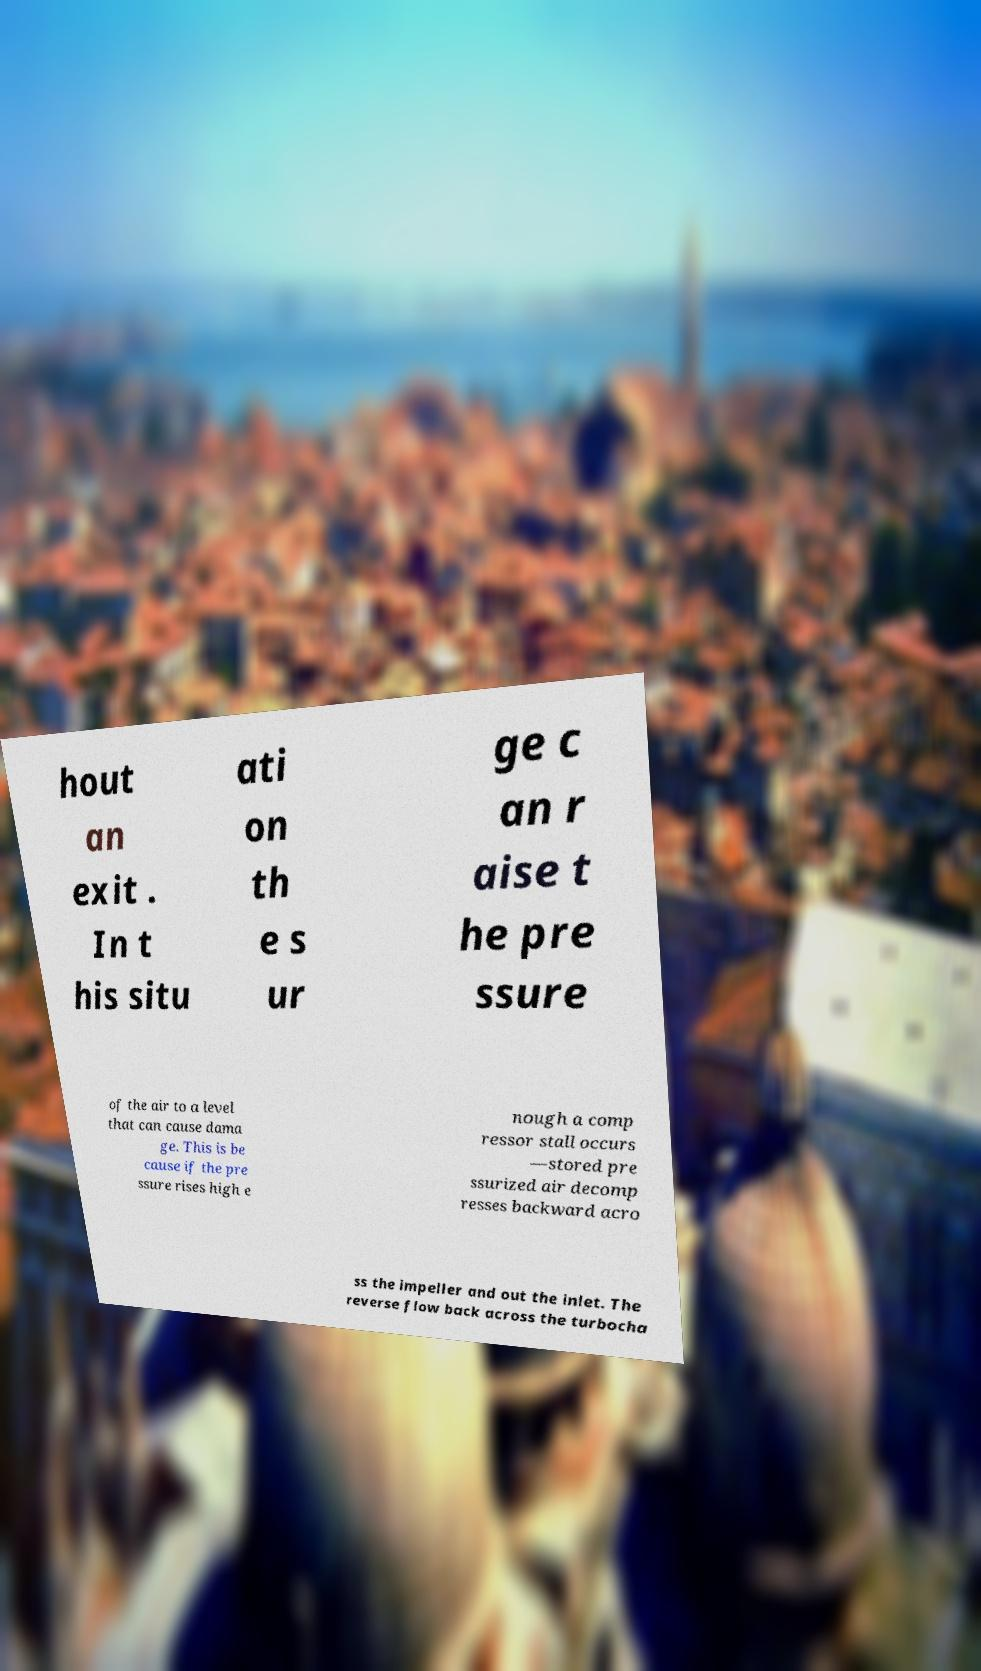Please identify and transcribe the text found in this image. hout an exit . In t his situ ati on th e s ur ge c an r aise t he pre ssure of the air to a level that can cause dama ge. This is be cause if the pre ssure rises high e nough a comp ressor stall occurs —stored pre ssurized air decomp resses backward acro ss the impeller and out the inlet. The reverse flow back across the turbocha 